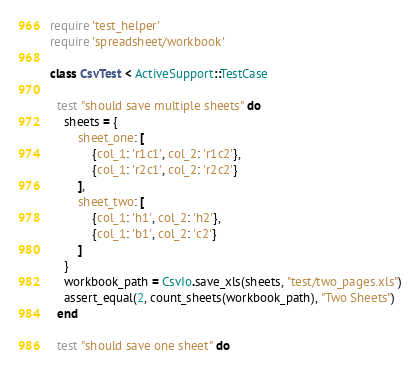Convert code to text. <code><loc_0><loc_0><loc_500><loc_500><_Ruby_>require 'test_helper'
require 'spreadsheet/workbook'

class CsvTest < ActiveSupport::TestCase

  test "should save multiple sheets" do
    sheets = {
        sheet_one: [
            {col_1: 'r1c1', col_2: 'r1c2'},
            {col_1: 'r2c1', col_2: 'r2c2'}
        ],
        sheet_two: [
            {col_1: 'h1', col_2: 'h2'},
            {col_1: 'b1', col_2: 'c2'}
        ]
    }
    workbook_path = CsvIo.save_xls(sheets, "test/two_pages.xls")
    assert_equal(2, count_sheets(workbook_path), "Two Sheets")
  end

  test "should save one sheet" do</code> 